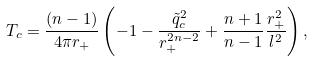<formula> <loc_0><loc_0><loc_500><loc_500>T _ { c } = \frac { ( n - 1 ) } { 4 \pi r _ { + } } \left ( - 1 - \frac { \tilde { q } ^ { 2 } _ { c } } { r _ { + } ^ { 2 n - 2 } } + \frac { n + 1 } { n - 1 } \frac { r _ { + } ^ { 2 } } { l ^ { 2 } } \right ) ,</formula> 